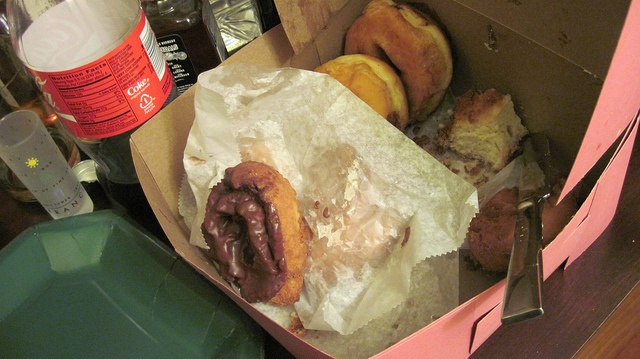Describe the objects in this image and their specific colors. I can see bottle in maroon, lightgray, black, brown, and red tones, donut in maroon, brown, orange, and black tones, donut in maroon, brown, and black tones, knife in maroon, black, and gray tones, and cup in maroon, gray, and olive tones in this image. 